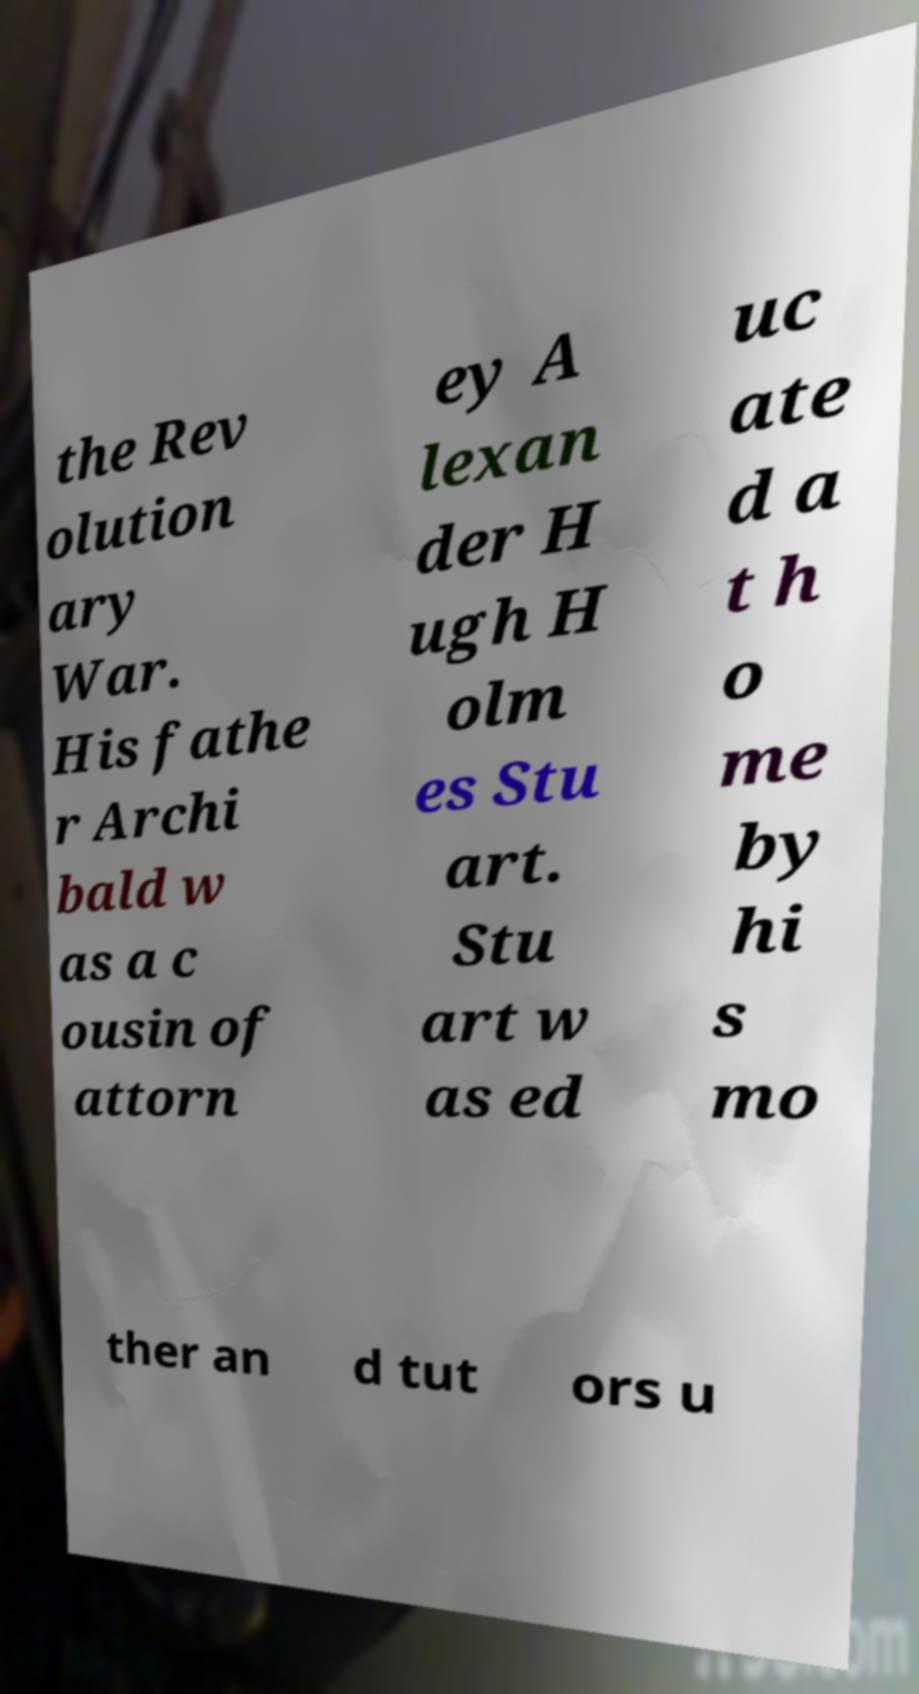Please read and relay the text visible in this image. What does it say? the Rev olution ary War. His fathe r Archi bald w as a c ousin of attorn ey A lexan der H ugh H olm es Stu art. Stu art w as ed uc ate d a t h o me by hi s mo ther an d tut ors u 